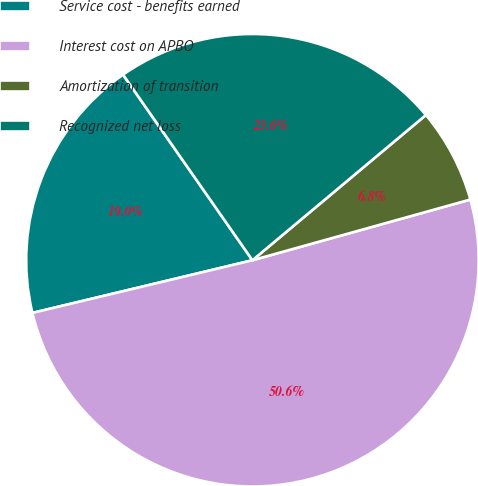Convert chart to OTSL. <chart><loc_0><loc_0><loc_500><loc_500><pie_chart><fcel>Service cost - benefits earned<fcel>Interest cost on APBO<fcel>Amortization of transition<fcel>Recognized net loss<nl><fcel>19.05%<fcel>50.59%<fcel>6.77%<fcel>23.6%<nl></chart> 